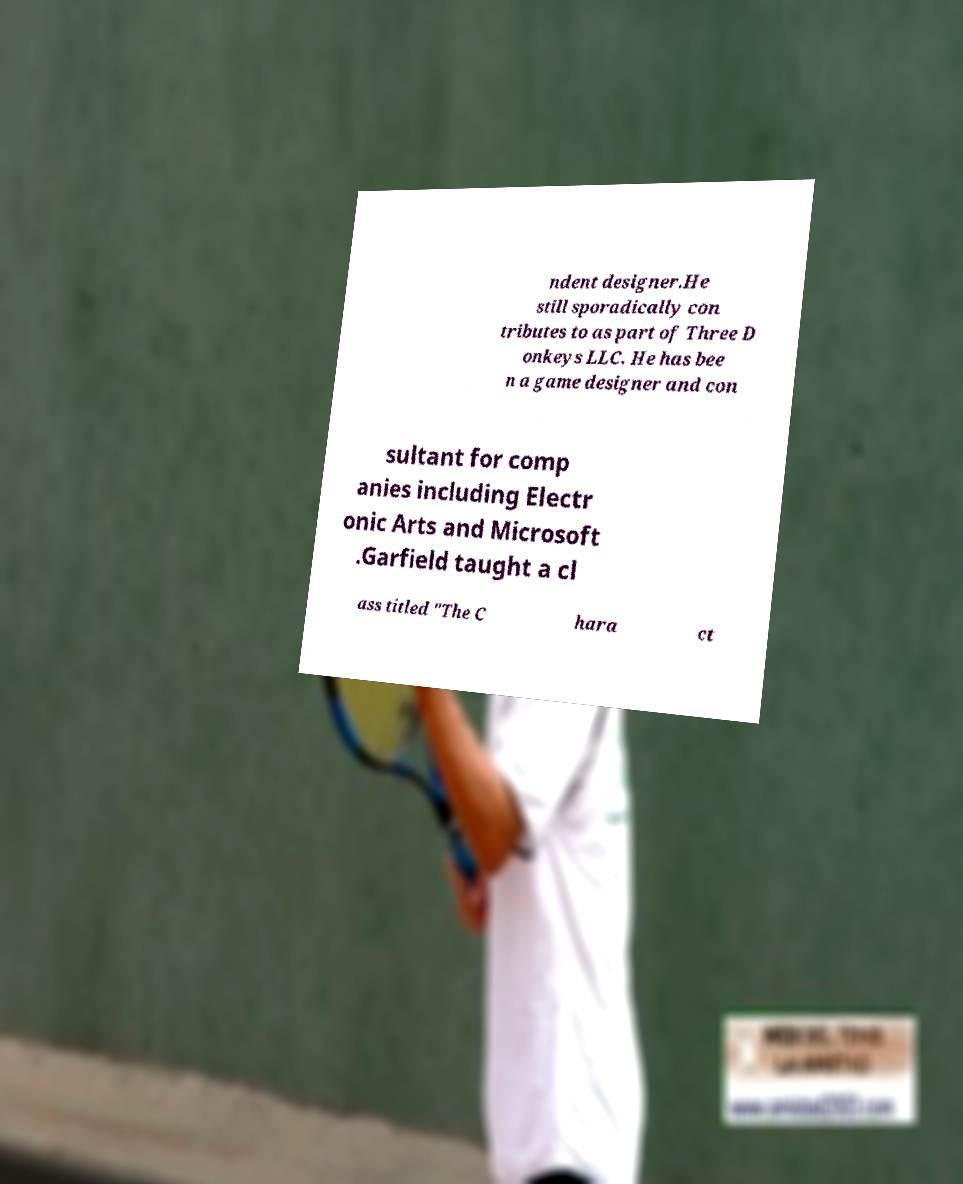Can you accurately transcribe the text from the provided image for me? ndent designer.He still sporadically con tributes to as part of Three D onkeys LLC. He has bee n a game designer and con sultant for comp anies including Electr onic Arts and Microsoft .Garfield taught a cl ass titled "The C hara ct 